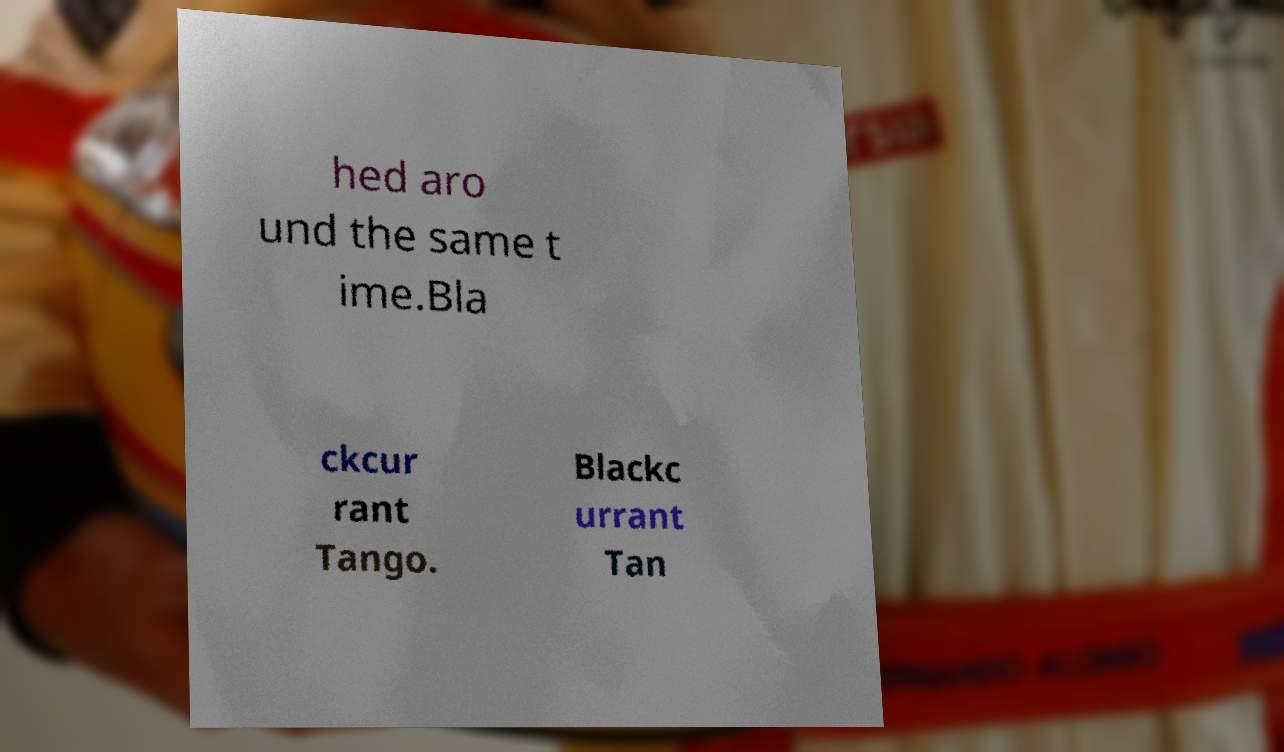Could you extract and type out the text from this image? hed aro und the same t ime.Bla ckcur rant Tango. Blackc urrant Tan 